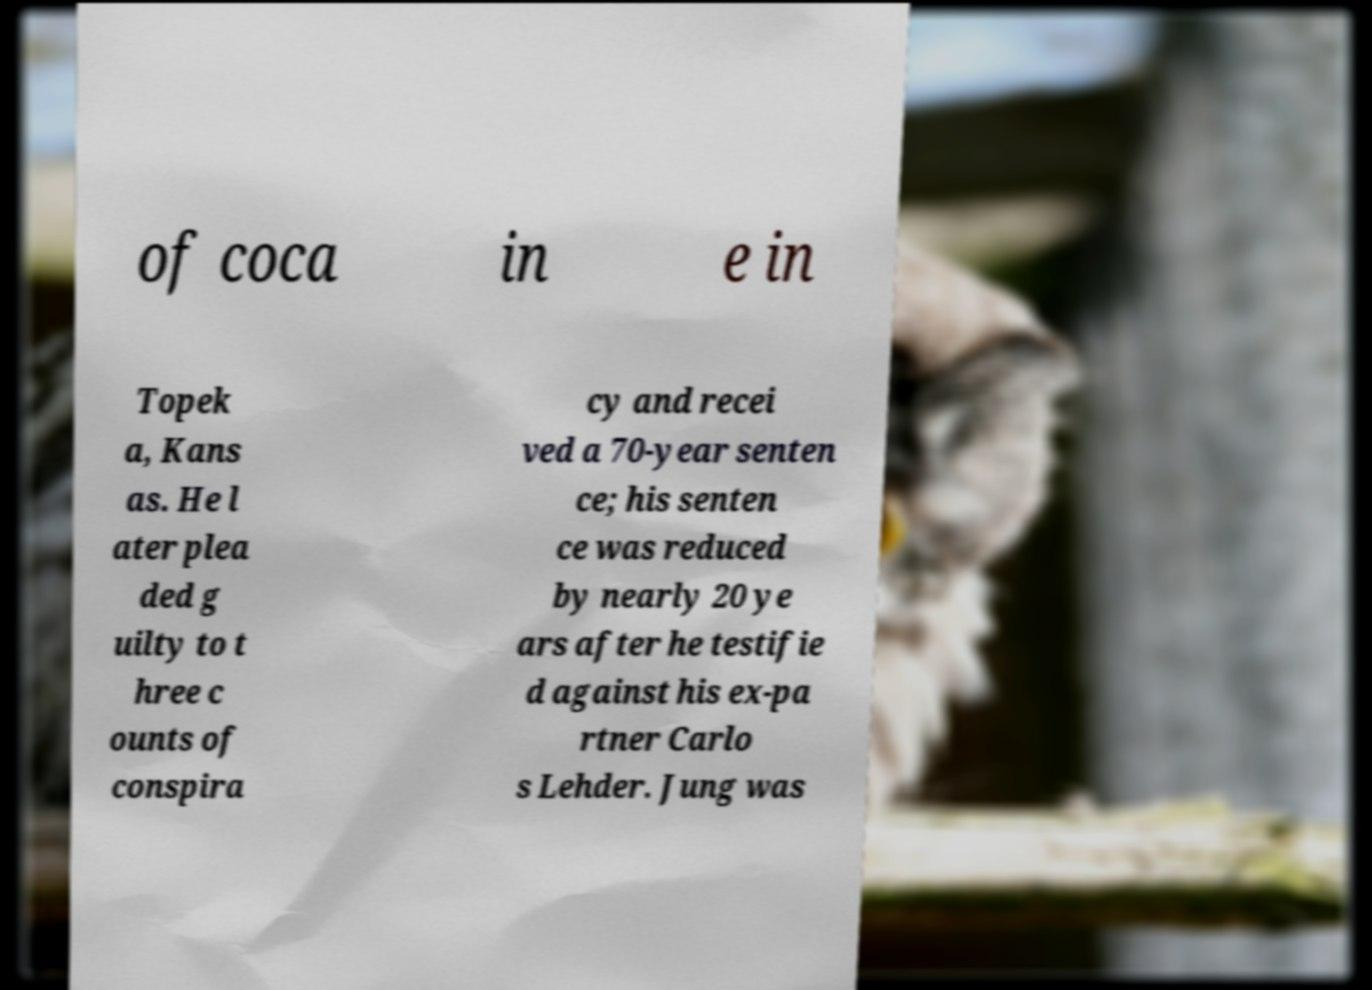What messages or text are displayed in this image? I need them in a readable, typed format. of coca in e in Topek a, Kans as. He l ater plea ded g uilty to t hree c ounts of conspira cy and recei ved a 70-year senten ce; his senten ce was reduced by nearly 20 ye ars after he testifie d against his ex-pa rtner Carlo s Lehder. Jung was 